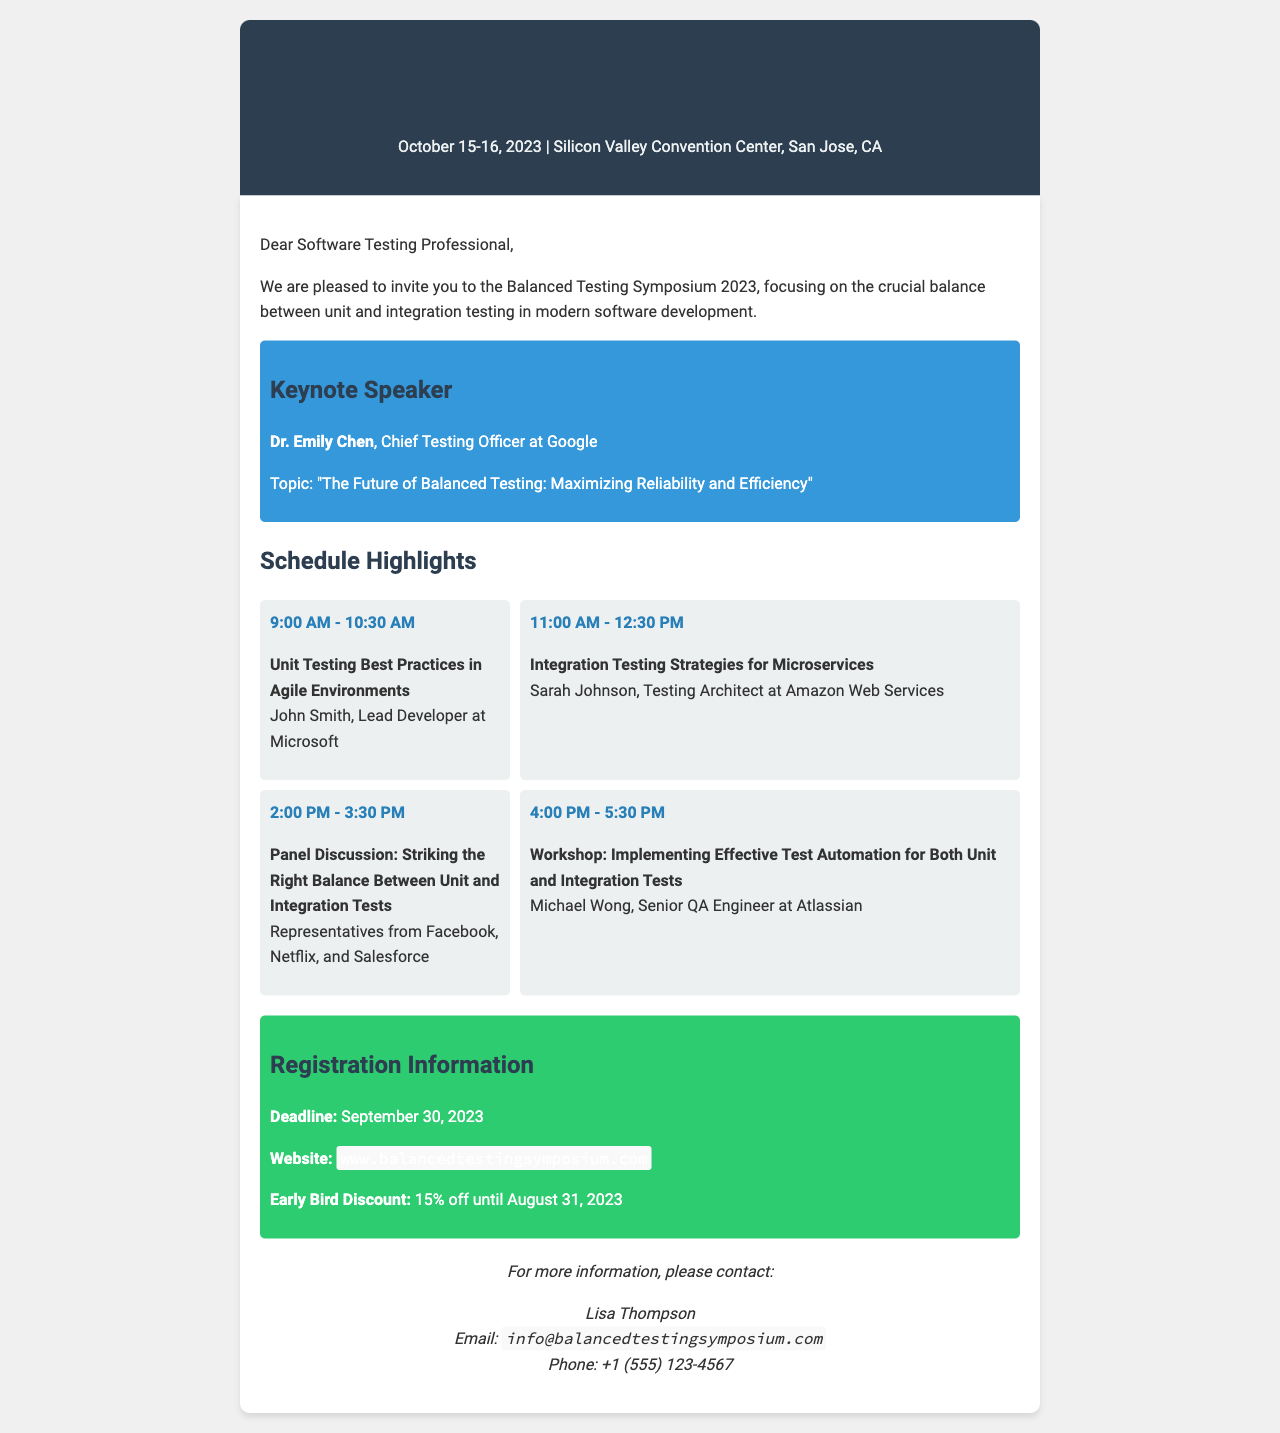What are the dates of the symposium? The dates of the symposium are specified at the top of the document, listing the event as taking place on October 15-16, 2023.
Answer: October 15-16, 2023 Who is the keynote speaker? The keynote speaker's name is mentioned in the keynote section of the document.
Answer: Dr. Emily Chen What is the title of the keynote speech? The title of the keynote speech is provided directly under the speaker's name in the keynote section.
Answer: The Future of Balanced Testing: Maximizing Reliability and Efficiency What time is the workshop scheduled for? The workshop time is found in the schedule section, detailing the specific time allocation.
Answer: 4:00 PM - 5:30 PM How much is the early bird discount percentage? The early bird discount percentage is included in the registration information section of the document.
Answer: 15% What is the name of the presenter for the panel discussion? The panel discussion section lists the presenters associated with the topic, indicating a group of representatives.
Answer: Representatives from Facebook, Netflix, and Salesforce What kind of strategies will be discussed at 11:00 AM? The type of strategies is specified alongside the presenter for that time slot in the schedule section.
Answer: Integration Testing Strategies for Microservices What is the registration deadline? The registration deadline is explicitly stated in the registration information section of the document.
Answer: September 30, 2023 